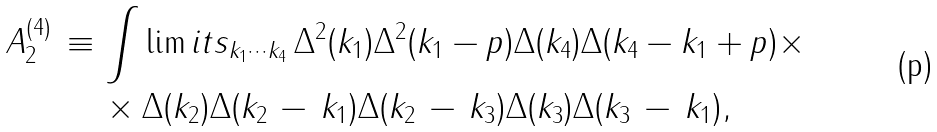Convert formula to latex. <formula><loc_0><loc_0><loc_500><loc_500>A _ { 2 } ^ { ( 4 ) } \, \equiv \, & \int \lim i t s _ { k _ { 1 } \cdots k _ { 4 } } \, \Delta ^ { 2 } ( k _ { 1 } ) \Delta ^ { 2 } ( k _ { 1 } - p ) \Delta ( k _ { 4 } ) \Delta ( k _ { 4 } - k _ { 1 } + p ) \times \\ & \times \Delta ( k _ { 2 } ) \Delta ( k _ { 2 } \, - \, k _ { 1 } ) \Delta ( k _ { 2 } \, - \, k _ { 3 } ) \Delta ( k _ { 3 } ) \Delta ( k _ { 3 } \, - \, k _ { 1 } ) ,</formula> 